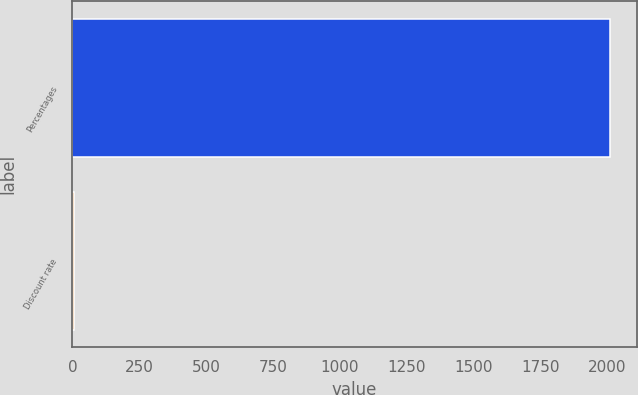<chart> <loc_0><loc_0><loc_500><loc_500><bar_chart><fcel>Percentages<fcel>Discount rate<nl><fcel>2009<fcel>6.25<nl></chart> 